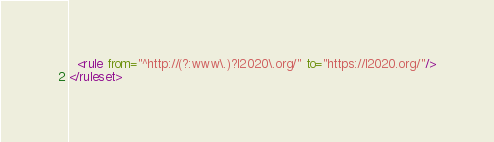<code> <loc_0><loc_0><loc_500><loc_500><_XML_>
  <rule from="^http://(?:www\.)?l2020\.org/" to="https://l2020.org/"/>
</ruleset>
</code> 